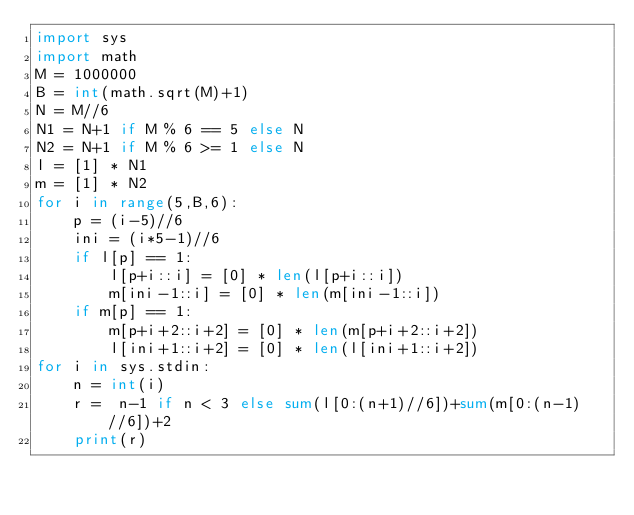<code> <loc_0><loc_0><loc_500><loc_500><_Python_>import sys
import math
M = 1000000
B = int(math.sqrt(M)+1)
N = M//6
N1 = N+1 if M % 6 == 5 else N
N2 = N+1 if M % 6 >= 1 else N
l = [1] * N1
m = [1] * N2
for i in range(5,B,6):
    p = (i-5)//6
    ini = (i*5-1)//6
    if l[p] == 1:
        l[p+i::i] = [0] * len(l[p+i::i])
        m[ini-1::i] = [0] * len(m[ini-1::i])
    if m[p] == 1:
        m[p+i+2::i+2] = [0] * len(m[p+i+2::i+2])
        l[ini+1::i+2] = [0] * len(l[ini+1::i+2])
for i in sys.stdin:
    n = int(i)
    r =  n-1 if n < 3 else sum(l[0:(n+1)//6])+sum(m[0:(n-1)//6])+2
    print(r)</code> 